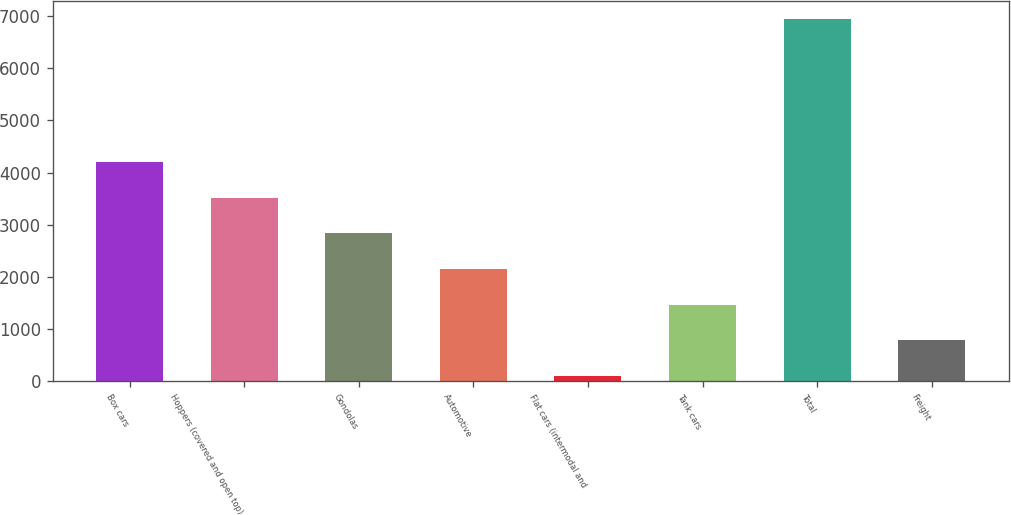Convert chart. <chart><loc_0><loc_0><loc_500><loc_500><bar_chart><fcel>Box cars<fcel>Hoppers (covered and open top)<fcel>Gondolas<fcel>Automotive<fcel>Flat cars (intermodal and<fcel>Tank cars<fcel>Total<fcel>Freight<nl><fcel>4202.8<fcel>3518.5<fcel>2834.2<fcel>2149.9<fcel>97<fcel>1465.6<fcel>6940<fcel>781.3<nl></chart> 